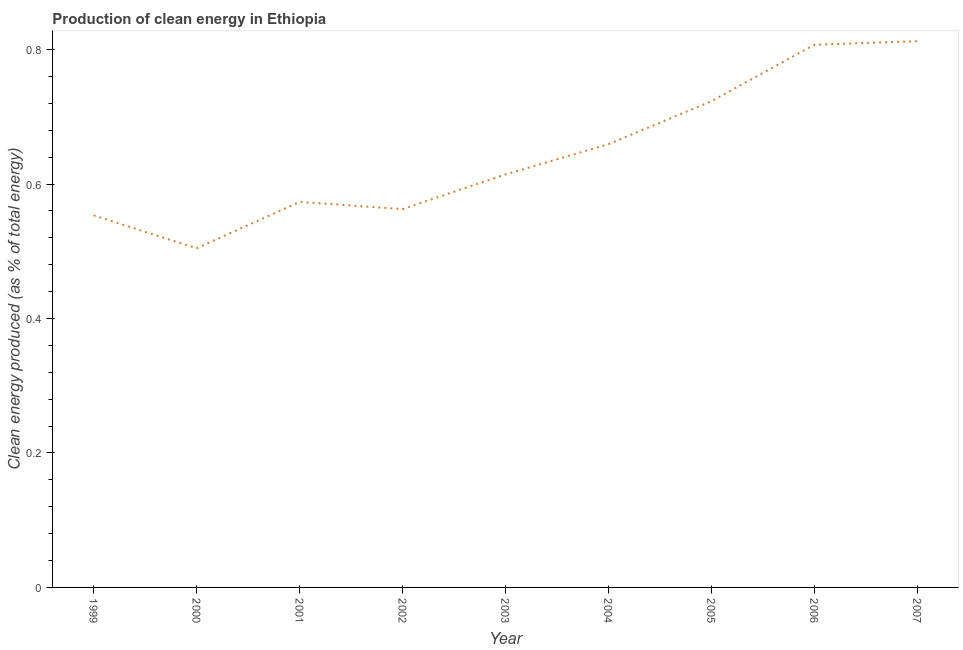What is the production of clean energy in 2003?
Your answer should be very brief. 0.61. Across all years, what is the maximum production of clean energy?
Offer a very short reply. 0.81. Across all years, what is the minimum production of clean energy?
Your response must be concise. 0.5. In which year was the production of clean energy minimum?
Your answer should be compact. 2000. What is the sum of the production of clean energy?
Your answer should be very brief. 5.81. What is the difference between the production of clean energy in 2003 and 2007?
Provide a short and direct response. -0.2. What is the average production of clean energy per year?
Offer a very short reply. 0.65. What is the median production of clean energy?
Your answer should be compact. 0.61. In how many years, is the production of clean energy greater than 0.52 %?
Ensure brevity in your answer.  8. Do a majority of the years between 2005 and 2007 (inclusive) have production of clean energy greater than 0.04 %?
Keep it short and to the point. Yes. What is the ratio of the production of clean energy in 2001 to that in 2006?
Give a very brief answer. 0.71. Is the difference between the production of clean energy in 2003 and 2006 greater than the difference between any two years?
Provide a succinct answer. No. What is the difference between the highest and the second highest production of clean energy?
Your answer should be compact. 0.01. Is the sum of the production of clean energy in 1999 and 2007 greater than the maximum production of clean energy across all years?
Provide a short and direct response. Yes. What is the difference between the highest and the lowest production of clean energy?
Keep it short and to the point. 0.31. Does the production of clean energy monotonically increase over the years?
Your answer should be compact. No. Are the values on the major ticks of Y-axis written in scientific E-notation?
Ensure brevity in your answer.  No. Does the graph contain grids?
Provide a succinct answer. No. What is the title of the graph?
Offer a terse response. Production of clean energy in Ethiopia. What is the label or title of the X-axis?
Keep it short and to the point. Year. What is the label or title of the Y-axis?
Your response must be concise. Clean energy produced (as % of total energy). What is the Clean energy produced (as % of total energy) in 1999?
Offer a very short reply. 0.55. What is the Clean energy produced (as % of total energy) in 2000?
Your response must be concise. 0.5. What is the Clean energy produced (as % of total energy) in 2001?
Offer a very short reply. 0.57. What is the Clean energy produced (as % of total energy) in 2002?
Ensure brevity in your answer.  0.56. What is the Clean energy produced (as % of total energy) of 2003?
Provide a short and direct response. 0.61. What is the Clean energy produced (as % of total energy) in 2004?
Provide a short and direct response. 0.66. What is the Clean energy produced (as % of total energy) in 2005?
Keep it short and to the point. 0.72. What is the Clean energy produced (as % of total energy) of 2006?
Offer a terse response. 0.81. What is the Clean energy produced (as % of total energy) of 2007?
Ensure brevity in your answer.  0.81. What is the difference between the Clean energy produced (as % of total energy) in 1999 and 2000?
Make the answer very short. 0.05. What is the difference between the Clean energy produced (as % of total energy) in 1999 and 2001?
Your answer should be compact. -0.02. What is the difference between the Clean energy produced (as % of total energy) in 1999 and 2002?
Your answer should be compact. -0.01. What is the difference between the Clean energy produced (as % of total energy) in 1999 and 2003?
Offer a very short reply. -0.06. What is the difference between the Clean energy produced (as % of total energy) in 1999 and 2004?
Your answer should be compact. -0.11. What is the difference between the Clean energy produced (as % of total energy) in 1999 and 2005?
Keep it short and to the point. -0.17. What is the difference between the Clean energy produced (as % of total energy) in 1999 and 2006?
Give a very brief answer. -0.25. What is the difference between the Clean energy produced (as % of total energy) in 1999 and 2007?
Your answer should be compact. -0.26. What is the difference between the Clean energy produced (as % of total energy) in 2000 and 2001?
Provide a short and direct response. -0.07. What is the difference between the Clean energy produced (as % of total energy) in 2000 and 2002?
Ensure brevity in your answer.  -0.06. What is the difference between the Clean energy produced (as % of total energy) in 2000 and 2003?
Ensure brevity in your answer.  -0.11. What is the difference between the Clean energy produced (as % of total energy) in 2000 and 2004?
Your answer should be very brief. -0.15. What is the difference between the Clean energy produced (as % of total energy) in 2000 and 2005?
Your answer should be very brief. -0.22. What is the difference between the Clean energy produced (as % of total energy) in 2000 and 2006?
Ensure brevity in your answer.  -0.3. What is the difference between the Clean energy produced (as % of total energy) in 2000 and 2007?
Offer a terse response. -0.31. What is the difference between the Clean energy produced (as % of total energy) in 2001 and 2002?
Your answer should be compact. 0.01. What is the difference between the Clean energy produced (as % of total energy) in 2001 and 2003?
Provide a short and direct response. -0.04. What is the difference between the Clean energy produced (as % of total energy) in 2001 and 2004?
Offer a very short reply. -0.09. What is the difference between the Clean energy produced (as % of total energy) in 2001 and 2005?
Your answer should be compact. -0.15. What is the difference between the Clean energy produced (as % of total energy) in 2001 and 2006?
Your answer should be compact. -0.23. What is the difference between the Clean energy produced (as % of total energy) in 2001 and 2007?
Provide a succinct answer. -0.24. What is the difference between the Clean energy produced (as % of total energy) in 2002 and 2003?
Offer a terse response. -0.05. What is the difference between the Clean energy produced (as % of total energy) in 2002 and 2004?
Make the answer very short. -0.1. What is the difference between the Clean energy produced (as % of total energy) in 2002 and 2005?
Provide a short and direct response. -0.16. What is the difference between the Clean energy produced (as % of total energy) in 2002 and 2006?
Give a very brief answer. -0.24. What is the difference between the Clean energy produced (as % of total energy) in 2002 and 2007?
Ensure brevity in your answer.  -0.25. What is the difference between the Clean energy produced (as % of total energy) in 2003 and 2004?
Your answer should be very brief. -0.04. What is the difference between the Clean energy produced (as % of total energy) in 2003 and 2005?
Give a very brief answer. -0.11. What is the difference between the Clean energy produced (as % of total energy) in 2003 and 2006?
Offer a terse response. -0.19. What is the difference between the Clean energy produced (as % of total energy) in 2003 and 2007?
Give a very brief answer. -0.2. What is the difference between the Clean energy produced (as % of total energy) in 2004 and 2005?
Make the answer very short. -0.06. What is the difference between the Clean energy produced (as % of total energy) in 2004 and 2006?
Provide a short and direct response. -0.15. What is the difference between the Clean energy produced (as % of total energy) in 2004 and 2007?
Provide a short and direct response. -0.15. What is the difference between the Clean energy produced (as % of total energy) in 2005 and 2006?
Your answer should be compact. -0.08. What is the difference between the Clean energy produced (as % of total energy) in 2005 and 2007?
Keep it short and to the point. -0.09. What is the difference between the Clean energy produced (as % of total energy) in 2006 and 2007?
Ensure brevity in your answer.  -0.01. What is the ratio of the Clean energy produced (as % of total energy) in 1999 to that in 2000?
Give a very brief answer. 1.1. What is the ratio of the Clean energy produced (as % of total energy) in 1999 to that in 2001?
Give a very brief answer. 0.96. What is the ratio of the Clean energy produced (as % of total energy) in 1999 to that in 2002?
Your answer should be very brief. 0.98. What is the ratio of the Clean energy produced (as % of total energy) in 1999 to that in 2003?
Your answer should be very brief. 0.9. What is the ratio of the Clean energy produced (as % of total energy) in 1999 to that in 2004?
Provide a succinct answer. 0.84. What is the ratio of the Clean energy produced (as % of total energy) in 1999 to that in 2005?
Your answer should be very brief. 0.77. What is the ratio of the Clean energy produced (as % of total energy) in 1999 to that in 2006?
Offer a terse response. 0.69. What is the ratio of the Clean energy produced (as % of total energy) in 1999 to that in 2007?
Provide a short and direct response. 0.68. What is the ratio of the Clean energy produced (as % of total energy) in 2000 to that in 2001?
Make the answer very short. 0.88. What is the ratio of the Clean energy produced (as % of total energy) in 2000 to that in 2002?
Your response must be concise. 0.9. What is the ratio of the Clean energy produced (as % of total energy) in 2000 to that in 2003?
Provide a succinct answer. 0.82. What is the ratio of the Clean energy produced (as % of total energy) in 2000 to that in 2004?
Ensure brevity in your answer.  0.77. What is the ratio of the Clean energy produced (as % of total energy) in 2000 to that in 2005?
Give a very brief answer. 0.7. What is the ratio of the Clean energy produced (as % of total energy) in 2000 to that in 2006?
Offer a very short reply. 0.62. What is the ratio of the Clean energy produced (as % of total energy) in 2000 to that in 2007?
Provide a short and direct response. 0.62. What is the ratio of the Clean energy produced (as % of total energy) in 2001 to that in 2002?
Keep it short and to the point. 1.02. What is the ratio of the Clean energy produced (as % of total energy) in 2001 to that in 2003?
Ensure brevity in your answer.  0.93. What is the ratio of the Clean energy produced (as % of total energy) in 2001 to that in 2004?
Make the answer very short. 0.87. What is the ratio of the Clean energy produced (as % of total energy) in 2001 to that in 2005?
Offer a terse response. 0.79. What is the ratio of the Clean energy produced (as % of total energy) in 2001 to that in 2006?
Provide a succinct answer. 0.71. What is the ratio of the Clean energy produced (as % of total energy) in 2001 to that in 2007?
Offer a terse response. 0.71. What is the ratio of the Clean energy produced (as % of total energy) in 2002 to that in 2003?
Your response must be concise. 0.92. What is the ratio of the Clean energy produced (as % of total energy) in 2002 to that in 2004?
Ensure brevity in your answer.  0.85. What is the ratio of the Clean energy produced (as % of total energy) in 2002 to that in 2005?
Give a very brief answer. 0.78. What is the ratio of the Clean energy produced (as % of total energy) in 2002 to that in 2006?
Offer a terse response. 0.7. What is the ratio of the Clean energy produced (as % of total energy) in 2002 to that in 2007?
Ensure brevity in your answer.  0.69. What is the ratio of the Clean energy produced (as % of total energy) in 2003 to that in 2004?
Ensure brevity in your answer.  0.93. What is the ratio of the Clean energy produced (as % of total energy) in 2003 to that in 2005?
Provide a short and direct response. 0.85. What is the ratio of the Clean energy produced (as % of total energy) in 2003 to that in 2006?
Your response must be concise. 0.76. What is the ratio of the Clean energy produced (as % of total energy) in 2003 to that in 2007?
Your answer should be very brief. 0.76. What is the ratio of the Clean energy produced (as % of total energy) in 2004 to that in 2005?
Your answer should be very brief. 0.91. What is the ratio of the Clean energy produced (as % of total energy) in 2004 to that in 2006?
Your answer should be compact. 0.82. What is the ratio of the Clean energy produced (as % of total energy) in 2004 to that in 2007?
Provide a short and direct response. 0.81. What is the ratio of the Clean energy produced (as % of total energy) in 2005 to that in 2006?
Provide a short and direct response. 0.9. What is the ratio of the Clean energy produced (as % of total energy) in 2005 to that in 2007?
Offer a very short reply. 0.89. 